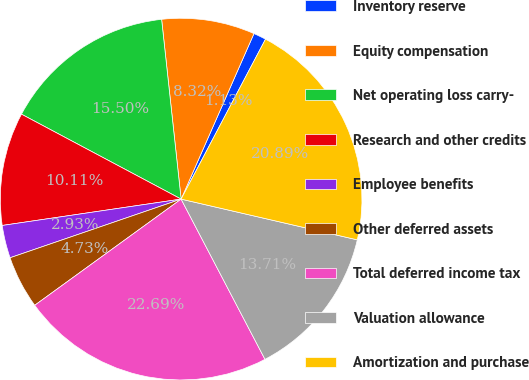<chart> <loc_0><loc_0><loc_500><loc_500><pie_chart><fcel>Inventory reserve<fcel>Equity compensation<fcel>Net operating loss carry-<fcel>Research and other credits<fcel>Employee benefits<fcel>Other deferred assets<fcel>Total deferred income tax<fcel>Valuation allowance<fcel>Amortization and purchase<nl><fcel>1.13%<fcel>8.32%<fcel>15.5%<fcel>10.11%<fcel>2.93%<fcel>4.73%<fcel>22.69%<fcel>13.71%<fcel>20.89%<nl></chart> 